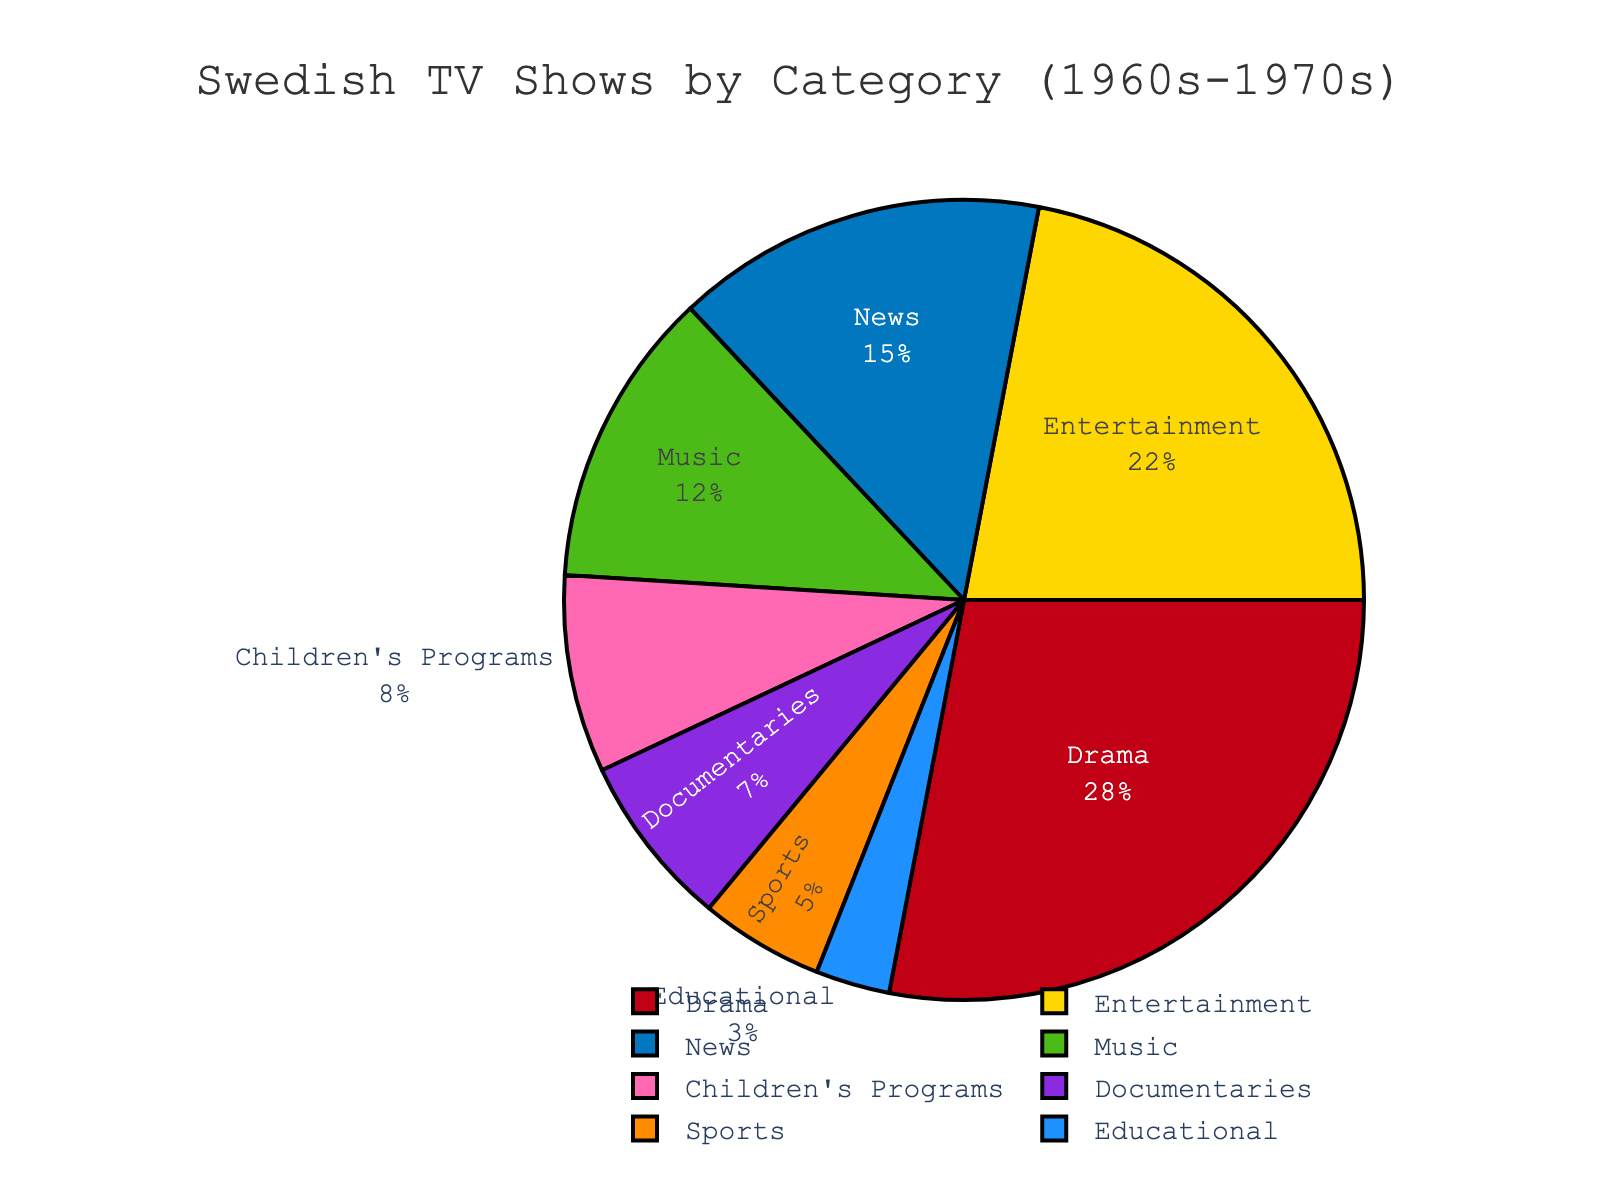Which category has the highest proportion of Swedish TV shows aired during prime time in the 1960s-1970s? The pie chart shows that the Drama category takes up the largest portion of the pie chart.
Answer: Drama Which two categories combined represent more than 40% of the total proportion? Drama (28%) and Entertainment (22%) together account for 50%, which is more than 40%.
Answer: Drama and Entertainment What's the difference in proportion between News and Music categories? The percentage for News is 15% and for Music is 12%. The difference is 15% - 12% = 3%.
Answer: 3% What category has the smallest proportion and what is its percentage? The Educational category is the smallest slice in the pie chart, representing 3%.
Answer: Educational, 3% If you sum the proportions of Music, Documentaries, and Educational categories, what do you get? Music (12%) + Documentaries (7%) + Educational (3%) = 22%.
Answer: 22% Which is greater, the combined percentage of Children's Programs and Sports, or News alone? Children's Programs (8%) + Sports (5%) = 13%, which is less than News at 15%.
Answer: News alone How do the proportions of Drama and Entertainment compare visually in the pie chart? The Drama section is visually the largest slice in the chart, followed by Entertainment which is slightly smaller.
Answer: Drama is larger than Entertainment What is the average proportion of News and Children's Programs categories? The percentage for News is 15% and for Children's Programs is 8%. The average is (15% + 8%) / 2 = 11.5%.
Answer: 11.5% Which categories combined make up exactly half of the total proportion of the chart? Drama (28%) + Entertainment (22%) = 50%. These two categories combined make up exactly half of the total proportion.
Answer: Drama and Entertainment Label the categories according to their smallest to largest proportions. The categories arranged from smallest to largest proportions are: Educational (3%), Sports (5%), Documentaries (7%), Children's Programs (8%), Music (12%), News (15%), Entertainment (22%), Drama (28%).
Answer: Educational, Sports, Documentaries, Children's Programs, Music, News, Entertainment, Drama 